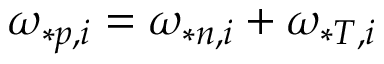Convert formula to latex. <formula><loc_0><loc_0><loc_500><loc_500>\omega _ { * p , i } = \omega _ { * n , i } + \omega _ { * T , i }</formula> 